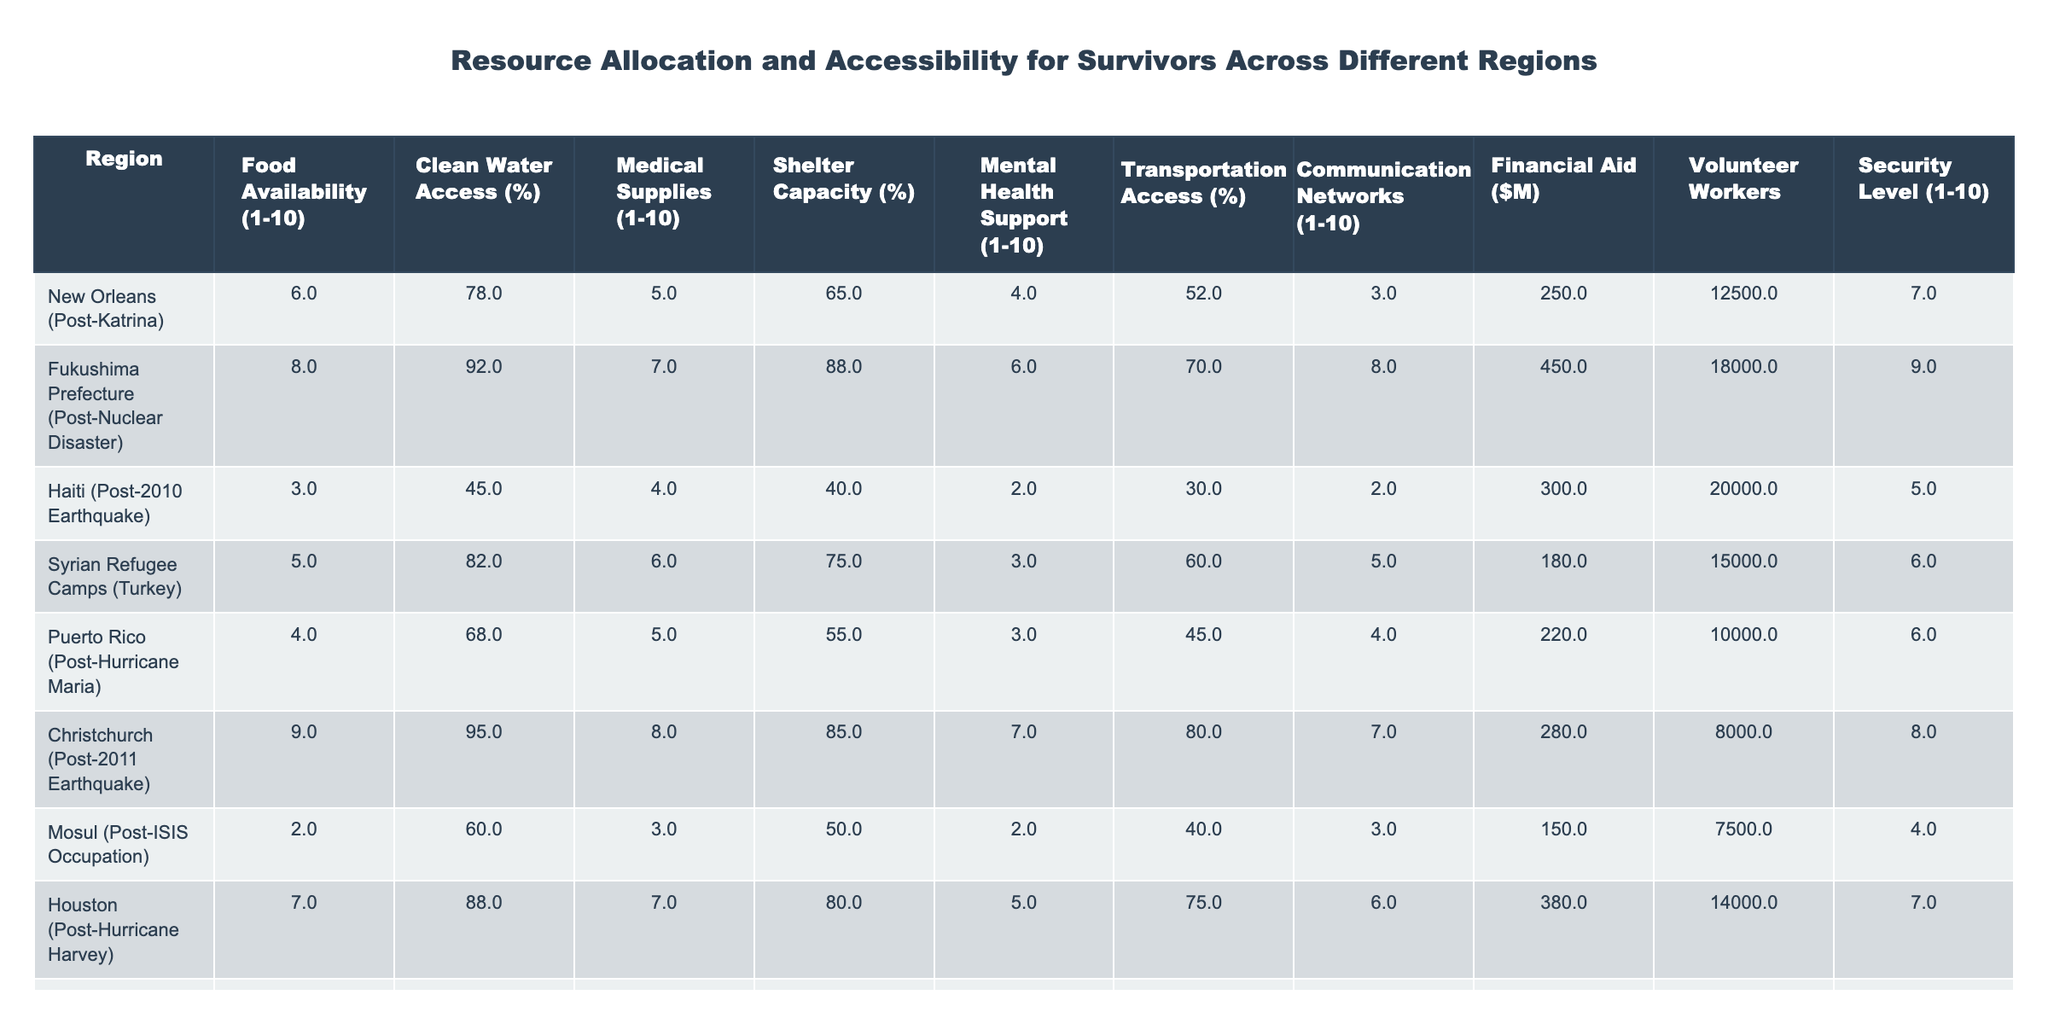What is the food availability rating for Fukushima Prefecture? The table lists the food availability rating for Fukushima Prefecture as 8.
Answer: 8 What percentage of clean water access is available in Haiti? According to the table, Haiti has a clean water access percentage of 45%.
Answer: 45% Which region has the highest shelter capacity percentage? By reviewing the shelter capacity percentages in the table, Christchurch with 85% has the highest.
Answer: Christchurch What is the medical supplies rating for Syrian Refugee Camps? The medical supplies rating for Syrian Refugee Camps is given as 6 in the table.
Answer: 6 Which region has the lowest mental health support rating? Upon examining the mental health support ratings, Haiti is noted with the lowest rating of 2.
Answer: Haiti What is the average transportation access percentage across all regions? To find the average, add the transportation access percentages (52 + 70 + 30 + 60 + 45 + 80 + 75 + 50 + 55) = 417, then divide by 9 (number of regions), giving 417/9 = 46.33.
Answer: 46.33 Do most regions have a security level of at least 5? Inspecting the security levels, we see that 5 out of 10 are below 5, so most regions do not have a security level of at least 5.
Answer: No What is the difference in medical supplies ratings between New Orleans and Christchurch? For New Orleans, the rating is 5 and for Christchurch, it is 8. The difference is 8 - 5 = 3.
Answer: 3 Which region has the highest level of volunteer workers and how many are there? By looking at the volunteer workers column, Haiti has the highest number at 20,000.
Answer: 20,000 Is the financial aid provided to Fukushima Prefecture greater than that provided to New Orleans? The table indicates that Fukushima received 450 million while New Orleans received 250 million; therefore, Fukushima has more.
Answer: Yes 